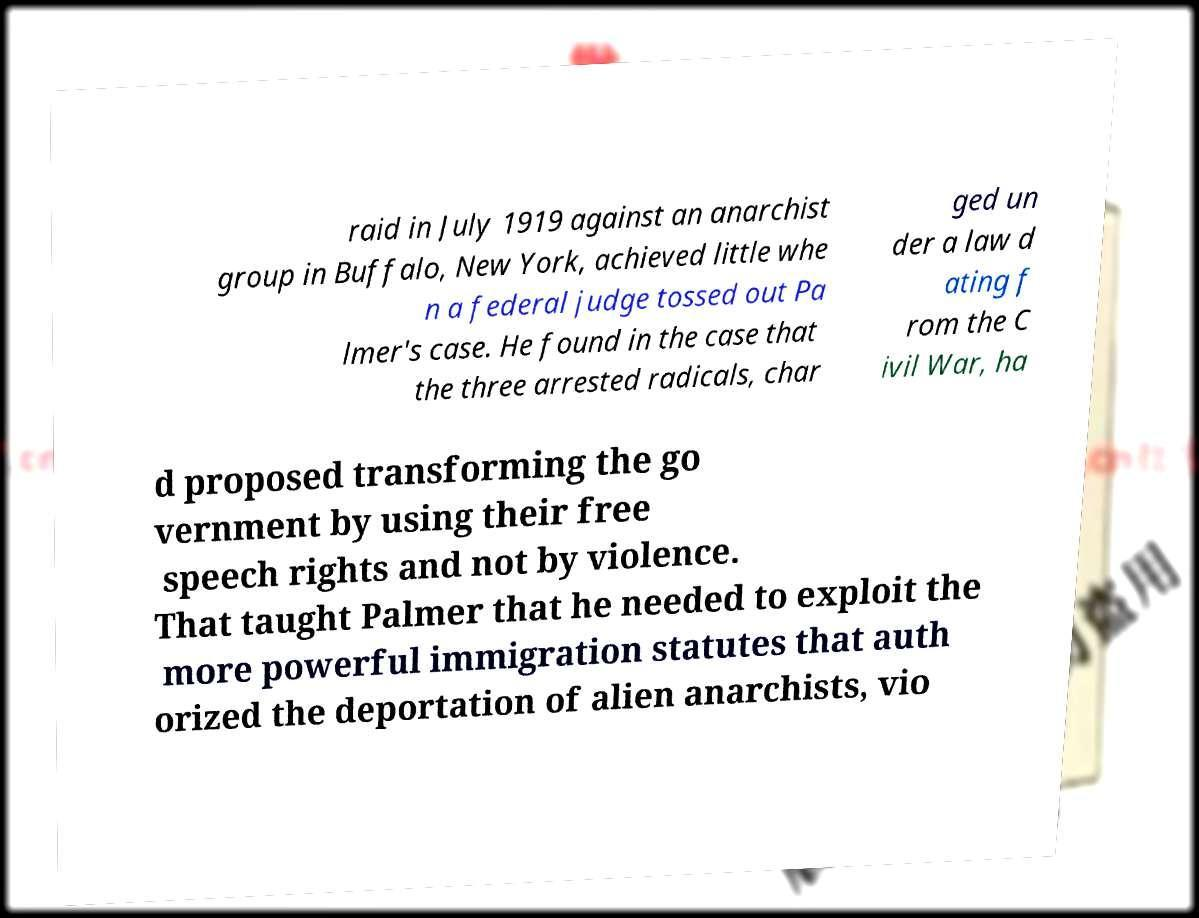For documentation purposes, I need the text within this image transcribed. Could you provide that? raid in July 1919 against an anarchist group in Buffalo, New York, achieved little whe n a federal judge tossed out Pa lmer's case. He found in the case that the three arrested radicals, char ged un der a law d ating f rom the C ivil War, ha d proposed transforming the go vernment by using their free speech rights and not by violence. That taught Palmer that he needed to exploit the more powerful immigration statutes that auth orized the deportation of alien anarchists, vio 